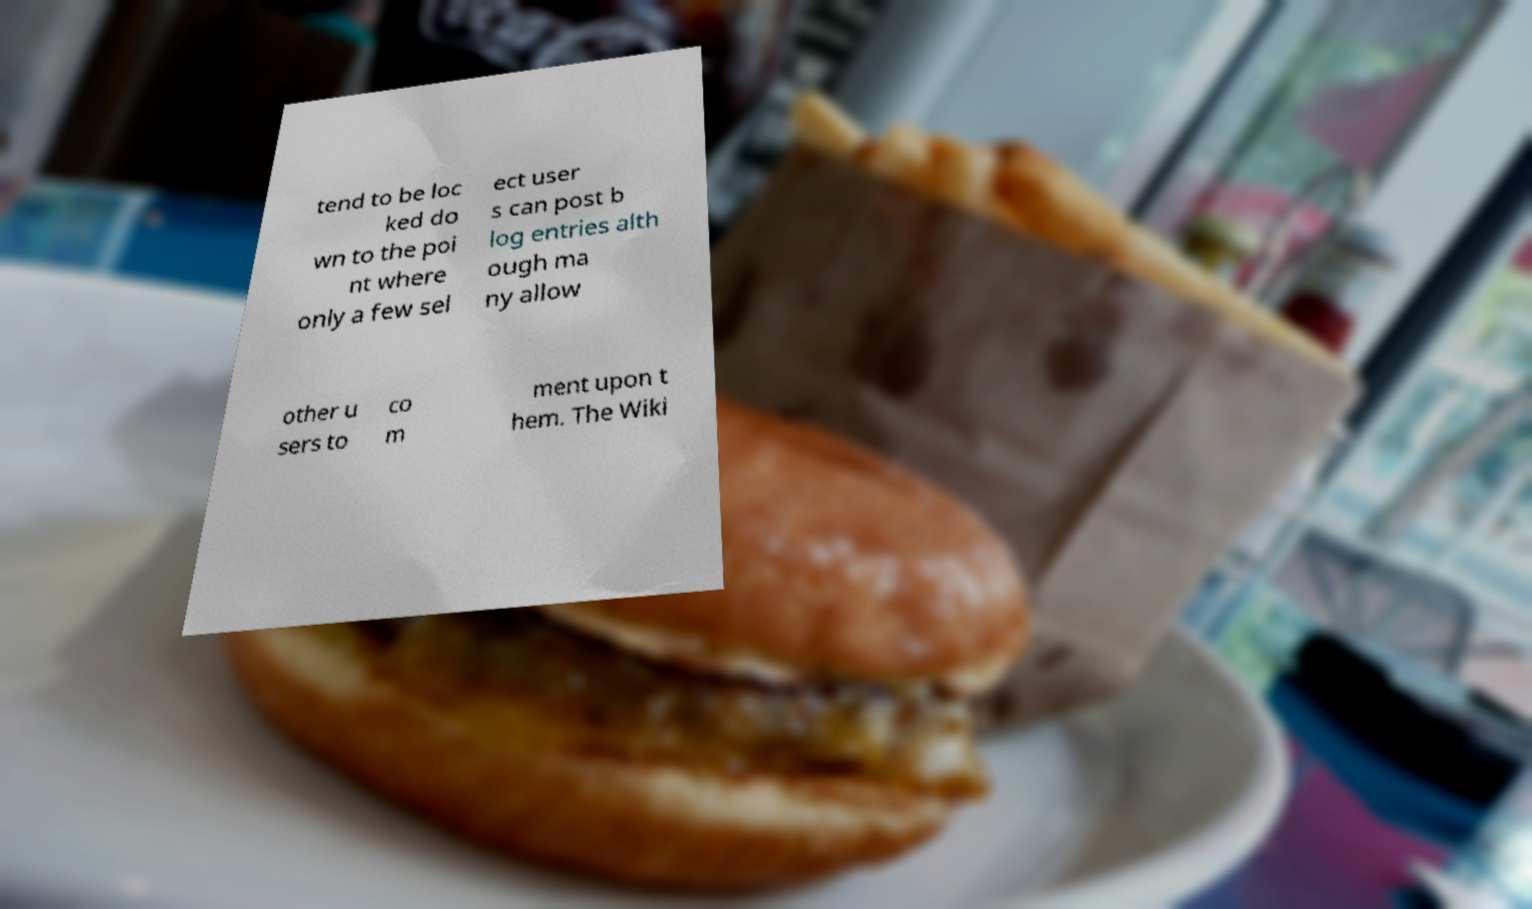Can you read and provide the text displayed in the image?This photo seems to have some interesting text. Can you extract and type it out for me? tend to be loc ked do wn to the poi nt where only a few sel ect user s can post b log entries alth ough ma ny allow other u sers to co m ment upon t hem. The Wiki 